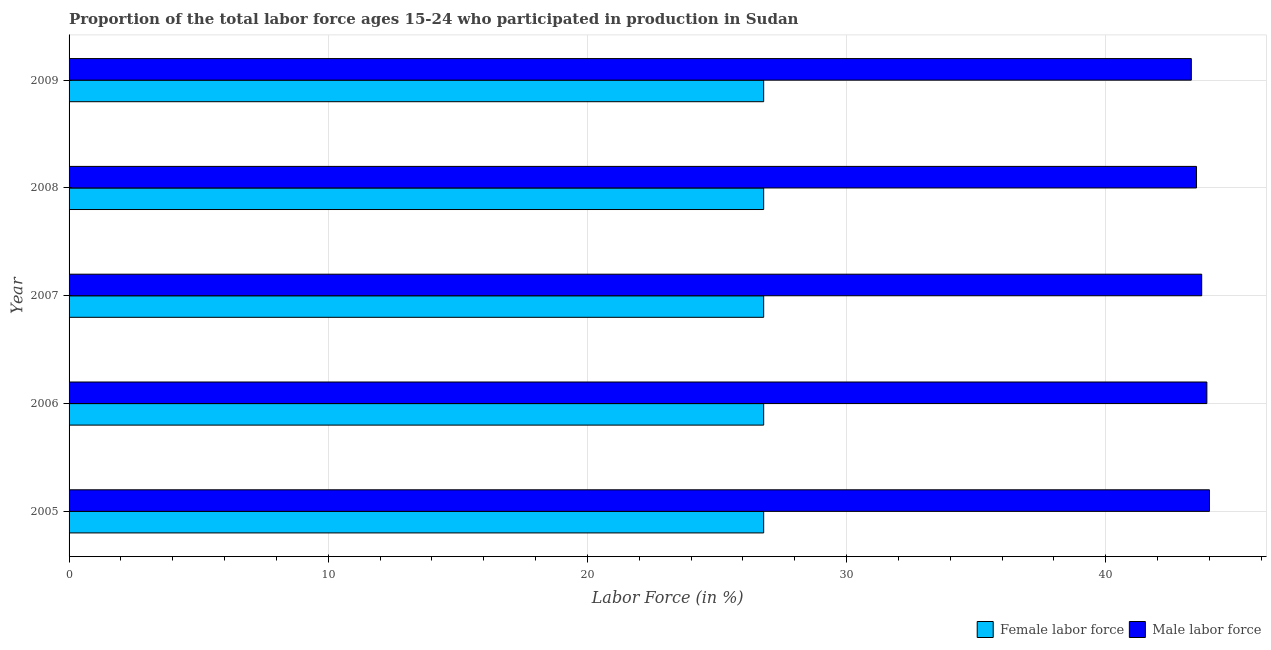How many groups of bars are there?
Your response must be concise. 5. What is the label of the 5th group of bars from the top?
Give a very brief answer. 2005. In how many cases, is the number of bars for a given year not equal to the number of legend labels?
Provide a short and direct response. 0. What is the percentage of male labour force in 2006?
Offer a terse response. 43.9. Across all years, what is the maximum percentage of female labor force?
Offer a very short reply. 26.8. Across all years, what is the minimum percentage of female labor force?
Provide a short and direct response. 26.8. What is the total percentage of female labor force in the graph?
Provide a succinct answer. 134. What is the difference between the percentage of female labor force in 2006 and that in 2009?
Offer a terse response. 0. What is the difference between the percentage of male labour force in 2009 and the percentage of female labor force in 2006?
Make the answer very short. 16.5. What is the average percentage of female labor force per year?
Provide a short and direct response. 26.8. What is the difference between the highest and the second highest percentage of female labor force?
Offer a terse response. 0. What is the difference between the highest and the lowest percentage of male labour force?
Give a very brief answer. 0.7. What does the 2nd bar from the top in 2009 represents?
Your answer should be compact. Female labor force. What does the 2nd bar from the bottom in 2008 represents?
Give a very brief answer. Male labor force. How many bars are there?
Provide a succinct answer. 10. Are all the bars in the graph horizontal?
Make the answer very short. Yes. Does the graph contain any zero values?
Keep it short and to the point. No. Where does the legend appear in the graph?
Give a very brief answer. Bottom right. How many legend labels are there?
Your response must be concise. 2. What is the title of the graph?
Make the answer very short. Proportion of the total labor force ages 15-24 who participated in production in Sudan. Does "Secondary school" appear as one of the legend labels in the graph?
Make the answer very short. No. What is the label or title of the X-axis?
Keep it short and to the point. Labor Force (in %). What is the Labor Force (in %) of Female labor force in 2005?
Give a very brief answer. 26.8. What is the Labor Force (in %) in Female labor force in 2006?
Provide a short and direct response. 26.8. What is the Labor Force (in %) in Male labor force in 2006?
Make the answer very short. 43.9. What is the Labor Force (in %) in Female labor force in 2007?
Provide a short and direct response. 26.8. What is the Labor Force (in %) in Male labor force in 2007?
Keep it short and to the point. 43.7. What is the Labor Force (in %) in Female labor force in 2008?
Provide a short and direct response. 26.8. What is the Labor Force (in %) in Male labor force in 2008?
Provide a succinct answer. 43.5. What is the Labor Force (in %) in Female labor force in 2009?
Give a very brief answer. 26.8. What is the Labor Force (in %) of Male labor force in 2009?
Your response must be concise. 43.3. Across all years, what is the maximum Labor Force (in %) of Female labor force?
Your response must be concise. 26.8. Across all years, what is the minimum Labor Force (in %) in Female labor force?
Give a very brief answer. 26.8. Across all years, what is the minimum Labor Force (in %) in Male labor force?
Your answer should be very brief. 43.3. What is the total Labor Force (in %) in Female labor force in the graph?
Keep it short and to the point. 134. What is the total Labor Force (in %) in Male labor force in the graph?
Your answer should be very brief. 218.4. What is the difference between the Labor Force (in %) of Male labor force in 2006 and that in 2007?
Offer a terse response. 0.2. What is the difference between the Labor Force (in %) of Female labor force in 2006 and that in 2009?
Provide a succinct answer. 0. What is the difference between the Labor Force (in %) of Male labor force in 2007 and that in 2008?
Your response must be concise. 0.2. What is the difference between the Labor Force (in %) in Female labor force in 2008 and that in 2009?
Provide a succinct answer. 0. What is the difference between the Labor Force (in %) of Female labor force in 2005 and the Labor Force (in %) of Male labor force in 2006?
Provide a short and direct response. -17.1. What is the difference between the Labor Force (in %) in Female labor force in 2005 and the Labor Force (in %) in Male labor force in 2007?
Make the answer very short. -16.9. What is the difference between the Labor Force (in %) in Female labor force in 2005 and the Labor Force (in %) in Male labor force in 2008?
Offer a very short reply. -16.7. What is the difference between the Labor Force (in %) in Female labor force in 2005 and the Labor Force (in %) in Male labor force in 2009?
Make the answer very short. -16.5. What is the difference between the Labor Force (in %) in Female labor force in 2006 and the Labor Force (in %) in Male labor force in 2007?
Provide a short and direct response. -16.9. What is the difference between the Labor Force (in %) in Female labor force in 2006 and the Labor Force (in %) in Male labor force in 2008?
Provide a short and direct response. -16.7. What is the difference between the Labor Force (in %) of Female labor force in 2006 and the Labor Force (in %) of Male labor force in 2009?
Your answer should be very brief. -16.5. What is the difference between the Labor Force (in %) in Female labor force in 2007 and the Labor Force (in %) in Male labor force in 2008?
Provide a succinct answer. -16.7. What is the difference between the Labor Force (in %) of Female labor force in 2007 and the Labor Force (in %) of Male labor force in 2009?
Keep it short and to the point. -16.5. What is the difference between the Labor Force (in %) of Female labor force in 2008 and the Labor Force (in %) of Male labor force in 2009?
Your answer should be compact. -16.5. What is the average Labor Force (in %) in Female labor force per year?
Your answer should be very brief. 26.8. What is the average Labor Force (in %) in Male labor force per year?
Offer a very short reply. 43.68. In the year 2005, what is the difference between the Labor Force (in %) in Female labor force and Labor Force (in %) in Male labor force?
Keep it short and to the point. -17.2. In the year 2006, what is the difference between the Labor Force (in %) of Female labor force and Labor Force (in %) of Male labor force?
Your answer should be compact. -17.1. In the year 2007, what is the difference between the Labor Force (in %) in Female labor force and Labor Force (in %) in Male labor force?
Your answer should be very brief. -16.9. In the year 2008, what is the difference between the Labor Force (in %) in Female labor force and Labor Force (in %) in Male labor force?
Offer a terse response. -16.7. In the year 2009, what is the difference between the Labor Force (in %) of Female labor force and Labor Force (in %) of Male labor force?
Offer a very short reply. -16.5. What is the ratio of the Labor Force (in %) in Male labor force in 2005 to that in 2006?
Offer a very short reply. 1. What is the ratio of the Labor Force (in %) in Male labor force in 2005 to that in 2008?
Give a very brief answer. 1.01. What is the ratio of the Labor Force (in %) in Female labor force in 2005 to that in 2009?
Offer a very short reply. 1. What is the ratio of the Labor Force (in %) in Male labor force in 2005 to that in 2009?
Your answer should be compact. 1.02. What is the ratio of the Labor Force (in %) in Female labor force in 2006 to that in 2007?
Make the answer very short. 1. What is the ratio of the Labor Force (in %) in Female labor force in 2006 to that in 2008?
Give a very brief answer. 1. What is the ratio of the Labor Force (in %) of Male labor force in 2006 to that in 2008?
Your answer should be very brief. 1.01. What is the ratio of the Labor Force (in %) in Female labor force in 2006 to that in 2009?
Make the answer very short. 1. What is the ratio of the Labor Force (in %) of Male labor force in 2006 to that in 2009?
Offer a very short reply. 1.01. What is the ratio of the Labor Force (in %) of Female labor force in 2007 to that in 2009?
Provide a succinct answer. 1. What is the ratio of the Labor Force (in %) of Male labor force in 2007 to that in 2009?
Ensure brevity in your answer.  1.01. What is the ratio of the Labor Force (in %) of Female labor force in 2008 to that in 2009?
Your response must be concise. 1. What is the difference between the highest and the second highest Labor Force (in %) of Female labor force?
Provide a succinct answer. 0. What is the difference between the highest and the second highest Labor Force (in %) of Male labor force?
Ensure brevity in your answer.  0.1. What is the difference between the highest and the lowest Labor Force (in %) of Female labor force?
Your answer should be very brief. 0. 